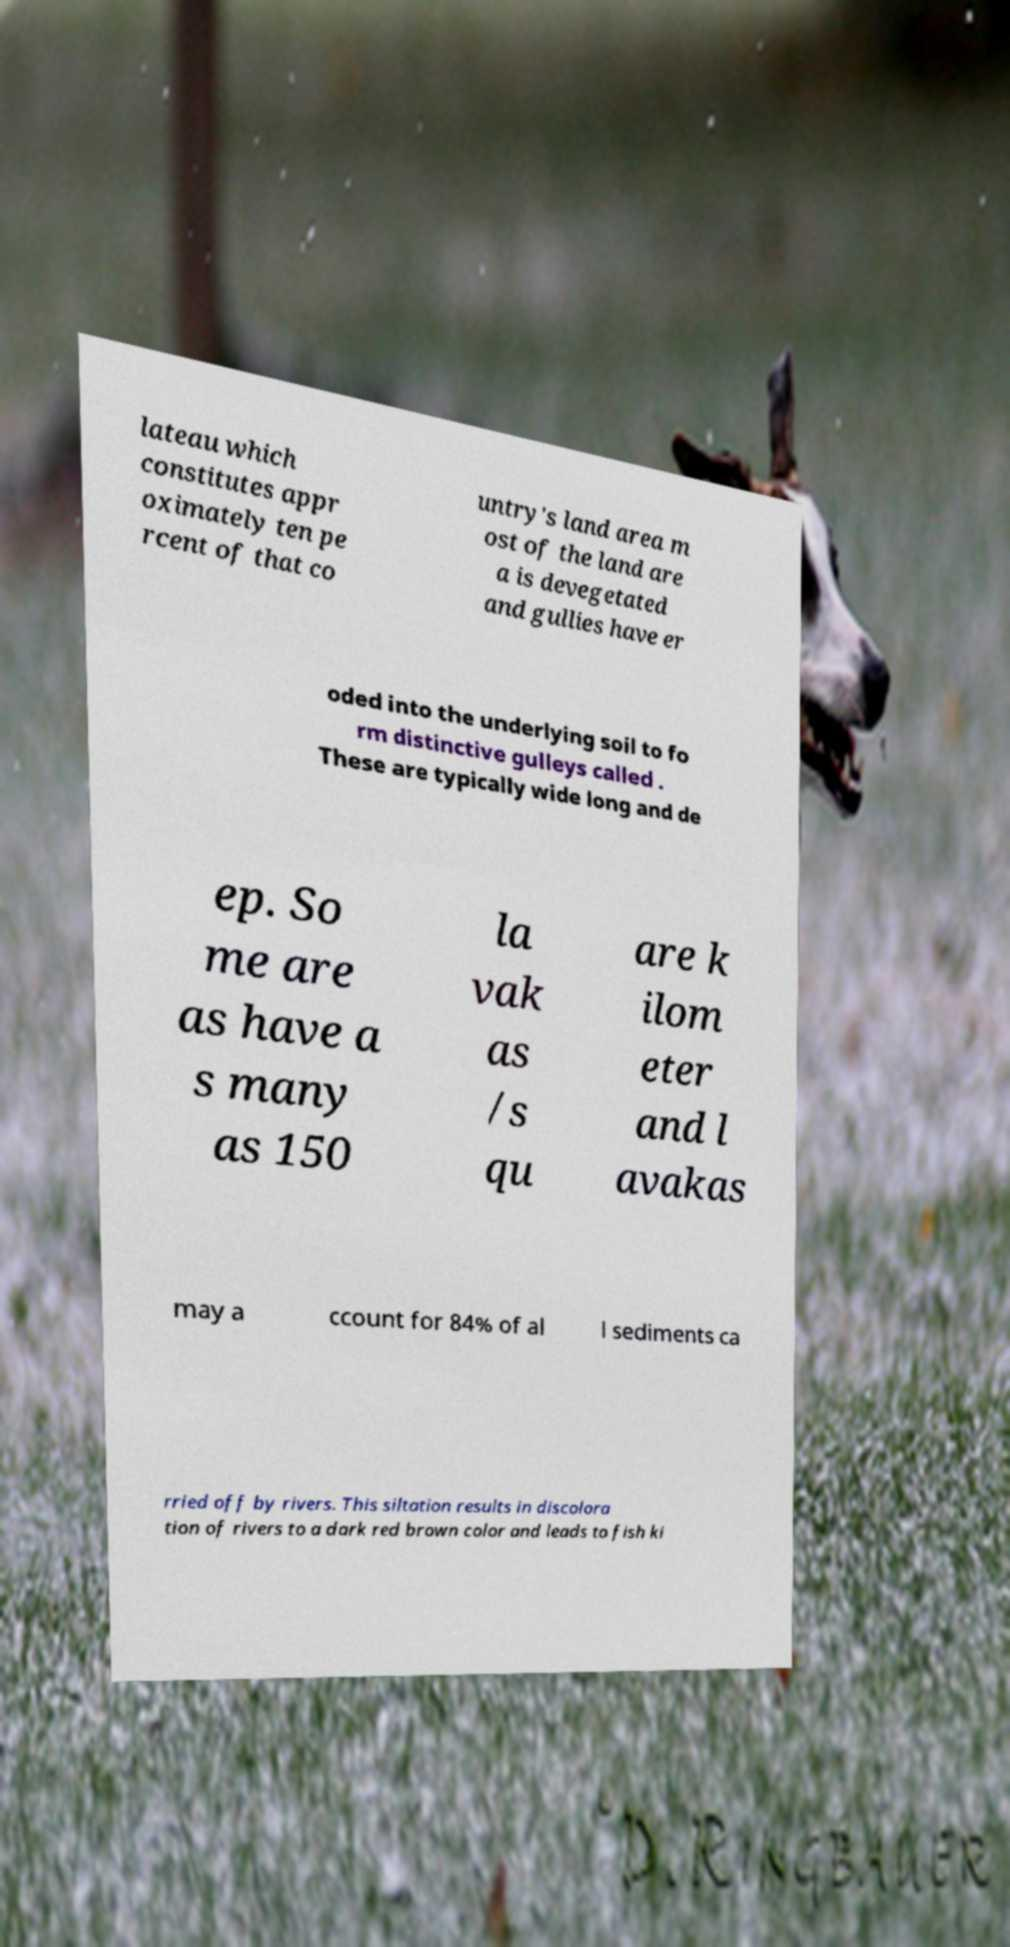Can you read and provide the text displayed in the image?This photo seems to have some interesting text. Can you extract and type it out for me? lateau which constitutes appr oximately ten pe rcent of that co untry's land area m ost of the land are a is devegetated and gullies have er oded into the underlying soil to fo rm distinctive gulleys called . These are typically wide long and de ep. So me are as have a s many as 150 la vak as /s qu are k ilom eter and l avakas may a ccount for 84% of al l sediments ca rried off by rivers. This siltation results in discolora tion of rivers to a dark red brown color and leads to fish ki 